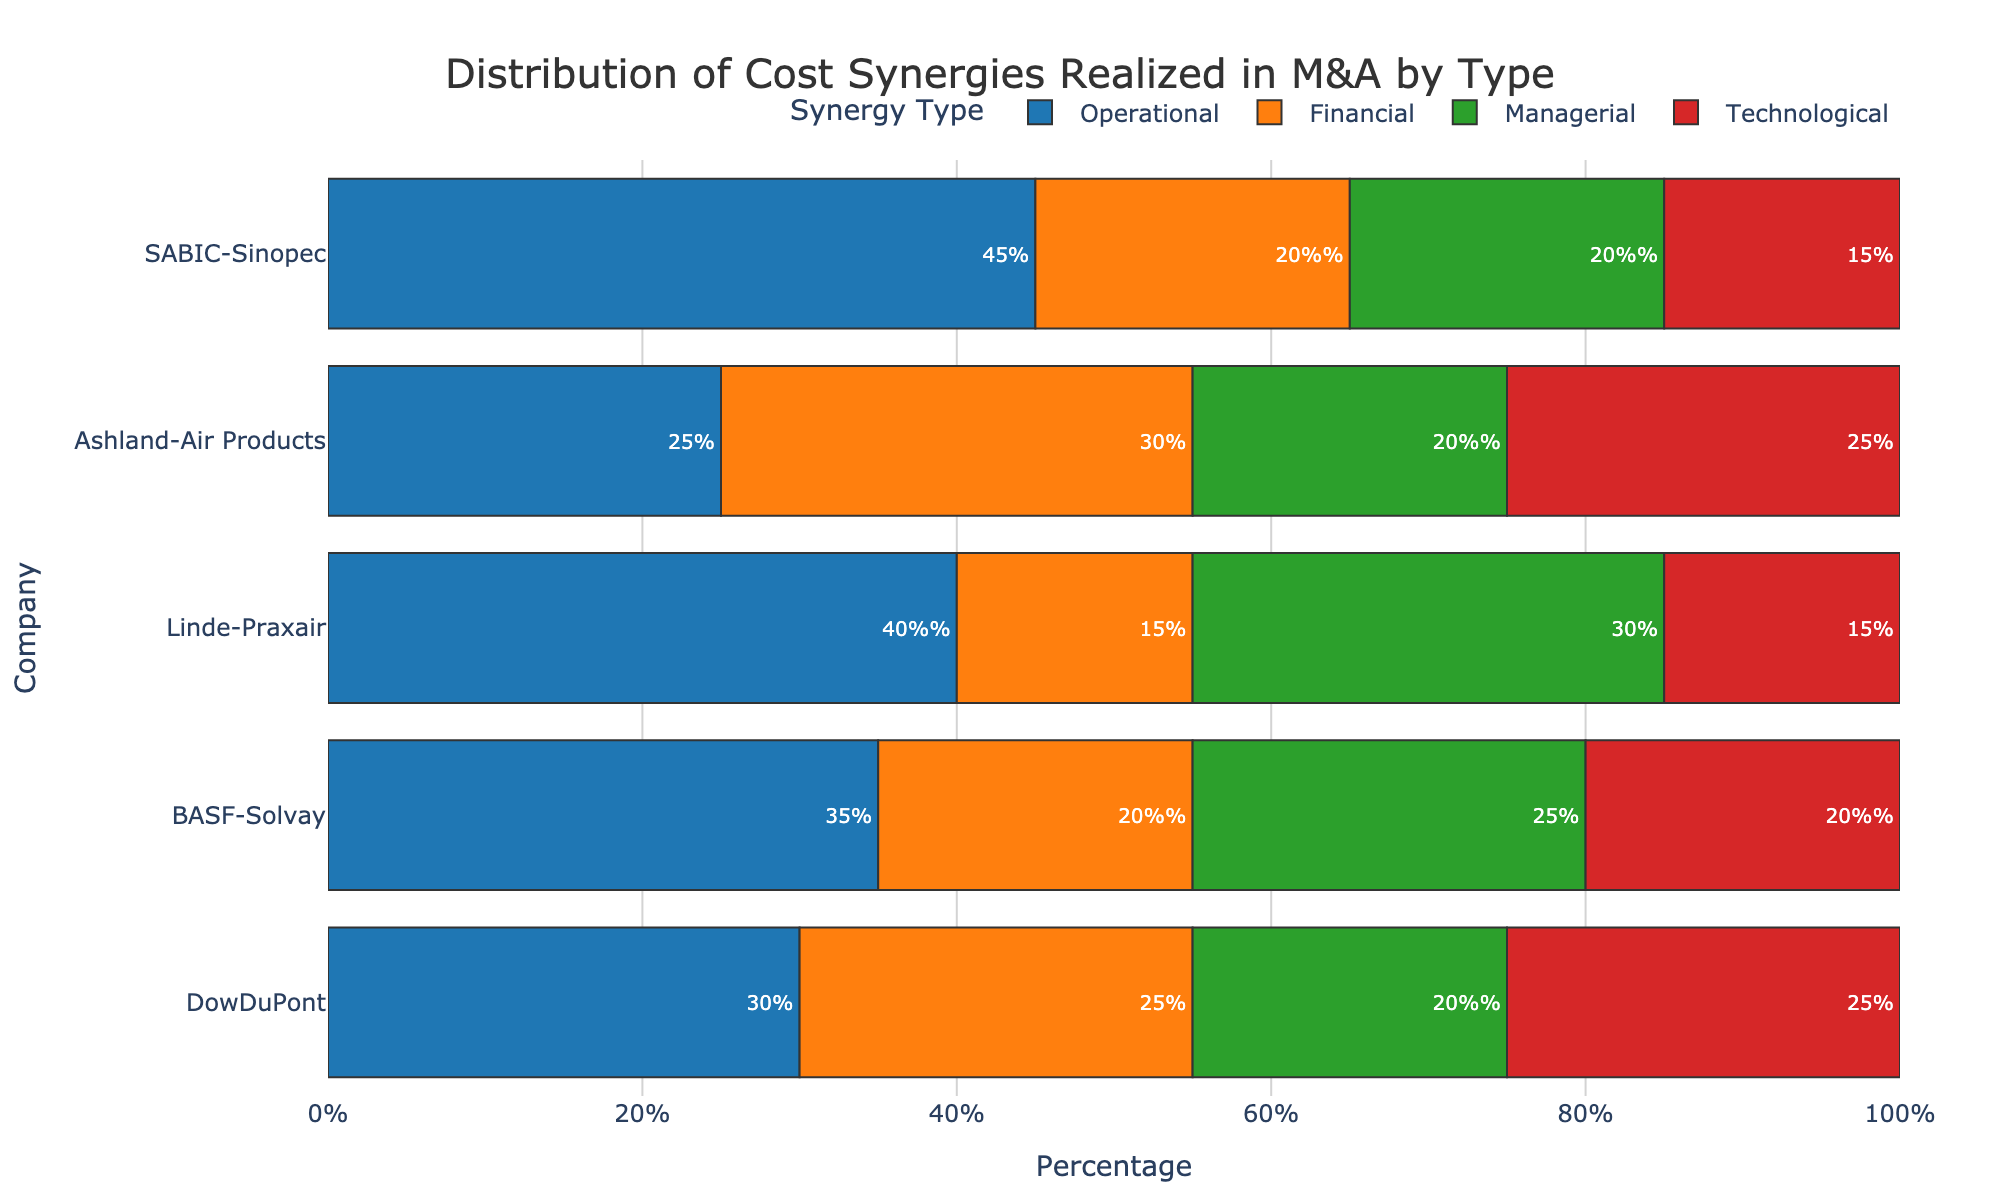Which company realized the highest operational cost synergy? Look for the highest bar under the 'Operational' category. SABIC-Sinopec has the highest operational percentage at 45%.
Answer: SABIC-Sinopec Among DowDuPont and BASF-Solvay, which company has a greater proportion of financial cost synergies? Compare the percentages under the 'Financial' category for both companies. DowDuPont has 25% while BASF-Solvay has 20%.
Answer: DowDuPont What is the total percentage of technological cost synergies for Linde-Praxair and Ashland-Air Products? Add the technological percentages for both companies. Linde-Praxair has 15% and Ashland-Air Products has 25%, summing up to 40%.
Answer: 40% Which type of synergy is the most common across all companies? Sum up the proportions for each synergy type across all companies, and compare the totals. Operational synergy appears most frequently with the highest overall percentage.
Answer: Operational How does SABIC-Sinopec's managerial synergy compare to their technological synergy? Observe and compare the two percentages for SABIC-Sinopec in 'Managerial' (20%) and 'Technological' (15%). Managerial is greater.
Answer: Managerial is greater Calculate the average percentage of operational cost synergies realized by all companies. Sum the operational percentages: 30% + 35% + 40% + 25% + 45%. The total is 175%. Divide by the number of companies (5), giving 35%.
Answer: 35% Which company has the most balanced distribution of synergies across all four types? Look for the company where the percentages of all four types are closest to each other. DowDuPont has values of 30%, 25%, 20%, and 25%.
Answer: DowDuPont Compare the overall managerial cost synergies to the overall financial cost synergies. Which is higher? Sum the managerial percentages: 20% + 25% + 30% + 20% + 20% = 115%. Sum the financial percentages: 25% + 20% + 15% + 30% + 20% = 110%. Managerial is higher.
Answer: Managerial What is the difference between SABIC-Sinopec's operational and financial synergies? Subtract the financial percentage from the operational percentage for SABIC-Sinopec: 45% - 20% = 25%.
Answer: 25% If we combine the managerial synergies of Ashland-Air Products and DowDuPont, what percentage do we get? Add the managerial percentages: Ashland-Air Products 20% + DowDuPont 20%, summing up to 40%.
Answer: 40% 